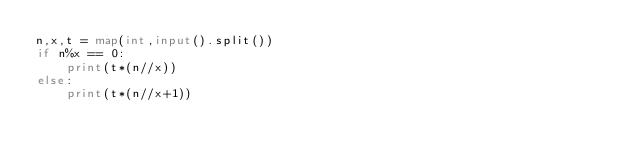Convert code to text. <code><loc_0><loc_0><loc_500><loc_500><_Python_>n,x,t = map(int,input().split())
if n%x == 0:
    print(t*(n//x))
else:
    print(t*(n//x+1))</code> 